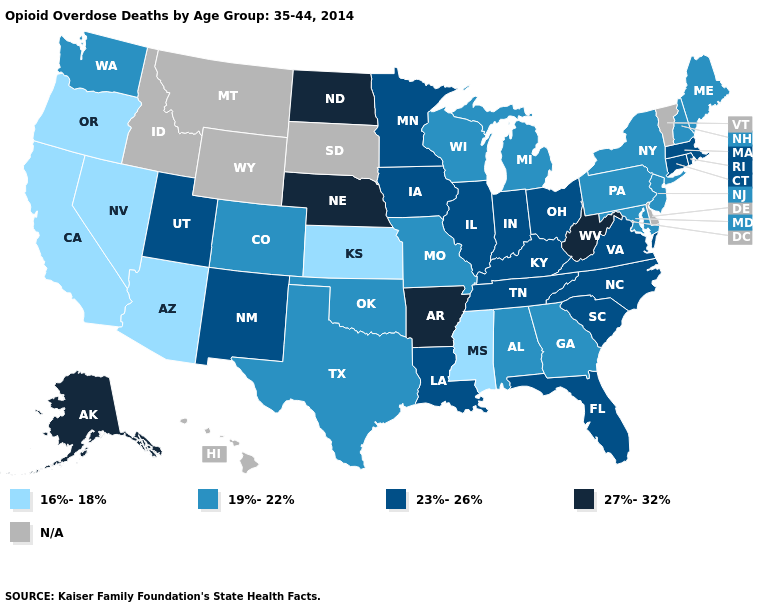Does Ohio have the lowest value in the MidWest?
Concise answer only. No. What is the value of Massachusetts?
Quick response, please. 23%-26%. What is the value of Minnesota?
Quick response, please. 23%-26%. Among the states that border South Dakota , does Nebraska have the lowest value?
Give a very brief answer. No. What is the highest value in states that border South Dakota?
Be succinct. 27%-32%. What is the value of Florida?
Answer briefly. 23%-26%. Name the states that have a value in the range 27%-32%?
Write a very short answer. Alaska, Arkansas, Nebraska, North Dakota, West Virginia. Which states have the lowest value in the South?
Answer briefly. Mississippi. Which states have the lowest value in the South?
Answer briefly. Mississippi. What is the highest value in the MidWest ?
Be succinct. 27%-32%. What is the value of New Mexico?
Write a very short answer. 23%-26%. Name the states that have a value in the range 16%-18%?
Answer briefly. Arizona, California, Kansas, Mississippi, Nevada, Oregon. Among the states that border Nevada , which have the lowest value?
Quick response, please. Arizona, California, Oregon. Does Maine have the highest value in the Northeast?
Answer briefly. No. 